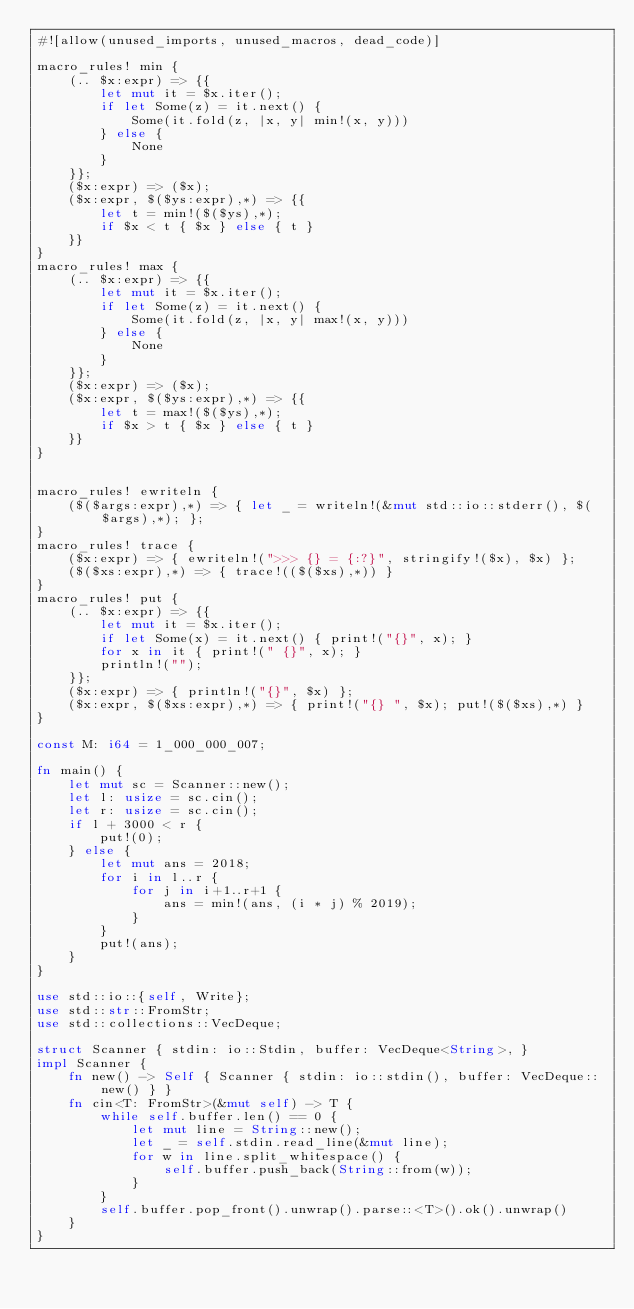Convert code to text. <code><loc_0><loc_0><loc_500><loc_500><_Rust_>#![allow(unused_imports, unused_macros, dead_code)]

macro_rules! min {
    (.. $x:expr) => {{
        let mut it = $x.iter();
        if let Some(z) = it.next() {
            Some(it.fold(z, |x, y| min!(x, y)))
        } else {
            None
        }
    }};
    ($x:expr) => ($x);
    ($x:expr, $($ys:expr),*) => {{
        let t = min!($($ys),*);
        if $x < t { $x } else { t }
    }}
}
macro_rules! max {
    (.. $x:expr) => {{
        let mut it = $x.iter();
        if let Some(z) = it.next() {
            Some(it.fold(z, |x, y| max!(x, y)))
        } else {
            None
        }
    }};
    ($x:expr) => ($x);
    ($x:expr, $($ys:expr),*) => {{
        let t = max!($($ys),*);
        if $x > t { $x } else { t }
    }}
}


macro_rules! ewriteln {
    ($($args:expr),*) => { let _ = writeln!(&mut std::io::stderr(), $($args),*); };
}
macro_rules! trace {
    ($x:expr) => { ewriteln!(">>> {} = {:?}", stringify!($x), $x) };
    ($($xs:expr),*) => { trace!(($($xs),*)) }
}
macro_rules! put {
    (.. $x:expr) => {{
        let mut it = $x.iter();
        if let Some(x) = it.next() { print!("{}", x); }
        for x in it { print!(" {}", x); }
        println!("");
    }};
    ($x:expr) => { println!("{}", $x) };
    ($x:expr, $($xs:expr),*) => { print!("{} ", $x); put!($($xs),*) }
}

const M: i64 = 1_000_000_007;

fn main() {
    let mut sc = Scanner::new();
    let l: usize = sc.cin();
    let r: usize = sc.cin();
    if l + 3000 < r {
        put!(0);
    } else {
        let mut ans = 2018;
        for i in l..r {
            for j in i+1..r+1 {
                ans = min!(ans, (i * j) % 2019);
            }
        }
        put!(ans);
    }
}

use std::io::{self, Write};
use std::str::FromStr;
use std::collections::VecDeque;

struct Scanner { stdin: io::Stdin, buffer: VecDeque<String>, }
impl Scanner {
    fn new() -> Self { Scanner { stdin: io::stdin(), buffer: VecDeque::new() } }
    fn cin<T: FromStr>(&mut self) -> T {
        while self.buffer.len() == 0 {
            let mut line = String::new();
            let _ = self.stdin.read_line(&mut line);
            for w in line.split_whitespace() {
                self.buffer.push_back(String::from(w));
            }
        }
        self.buffer.pop_front().unwrap().parse::<T>().ok().unwrap()
    }
}
</code> 